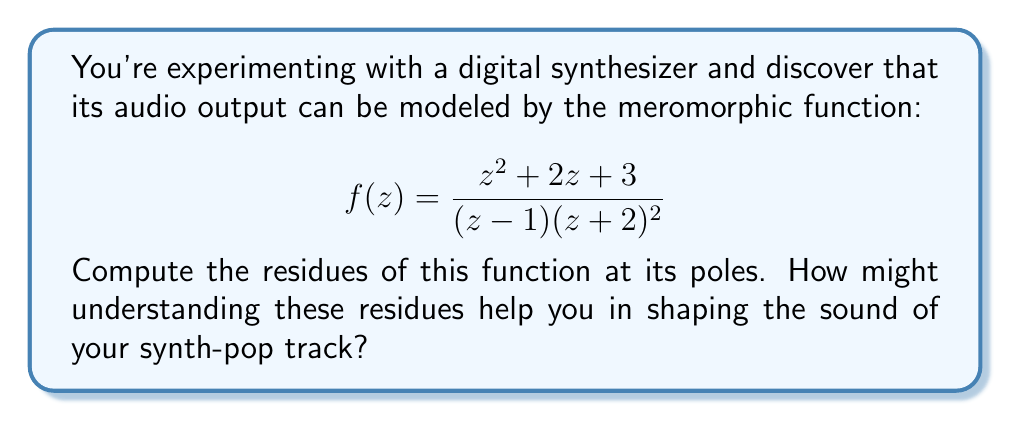Can you answer this question? Let's approach this step-by-step:

1) First, we need to identify the poles of the function. The poles are at $z=1$ and $z=-2$. The pole at $z=1$ is simple (order 1), while the pole at $z=-2$ is of order 2.

2) For the simple pole at $z=1$:
   The residue can be calculated using the formula:
   $$\text{Res}(f,1) = \lim_{z \to 1} (z-1)f(z)$$
   
   $$\begin{align*}
   \text{Res}(f,1) &= \lim_{z \to 1} (z-1)\frac{z^2 + 2z + 3}{(z-1)(z+2)^2} \\
   &= \lim_{z \to 1} \frac{z^2 + 2z + 3}{(z+2)^2} \\
   &= \frac{1^2 + 2(1) + 3}{(1+2)^2} = \frac{6}{9} = \frac{2}{3}
   \end{align*}$$

3) For the double pole at $z=-2$:
   For a pole of order 2, we use the formula:
   $$\text{Res}(f,-2) = \lim_{z \to -2} \frac{d}{dz}[(z+2)^2f(z)]$$
   
   $$\begin{align*}
   \text{Res}(f,-2) &= \lim_{z \to -2} \frac{d}{dz}[(z+2)^2\frac{z^2 + 2z + 3}{(z-1)(z+2)^2}] \\
   &= \lim_{z \to -2} \frac{d}{dz}[\frac{z^2 + 2z + 3}{z-1}] \\
   &= \lim_{z \to -2} \frac{(z-1)(2z+2) - (z^2+2z+3)(-1)}{(z-1)^2} \\
   &= \frac{(-2-1)(2(-2)+2) - ((-2)^2+2(-2)+3)(-1)}{(-2-1)^2} \\
   &= \frac{-3(-2) - (4-4+3)(-1)}{9} = \frac{6-3}{9} = \frac{1}{3}
   \end{align*}$$

Understanding these residues can help in shaping the sound of a synth-pop track because residues are related to the frequency components of the signal. The magnitude of the residues can indicate the strength of certain frequencies in the output, while the complex arguments of the residues can provide information about phase shifts. This knowledge can be used to emphasize or de-emphasize certain frequencies, creating unique timbres and textures in the synthesized sound.
Answer: The residues are:
At $z=1$: $\text{Res}(f,1) = \frac{2}{3}$
At $z=-2$: $\text{Res}(f,-2) = \frac{1}{3}$ 